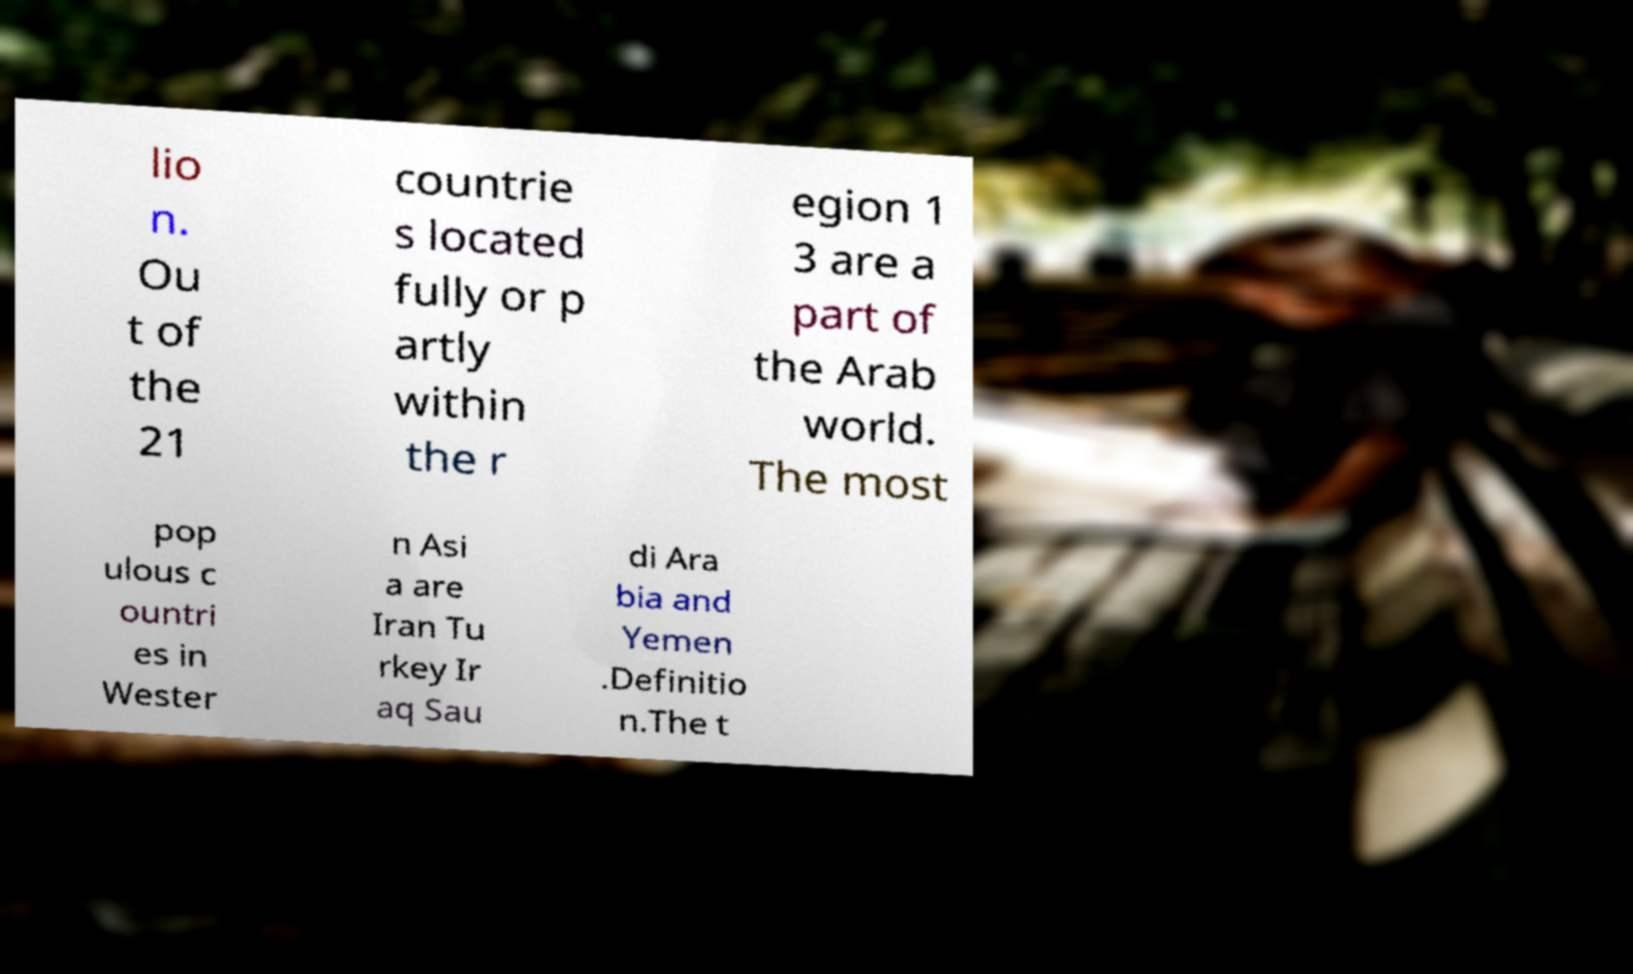Please identify and transcribe the text found in this image. lio n. Ou t of the 21 countrie s located fully or p artly within the r egion 1 3 are a part of the Arab world. The most pop ulous c ountri es in Wester n Asi a are Iran Tu rkey Ir aq Sau di Ara bia and Yemen .Definitio n.The t 